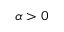Convert formula to latex. <formula><loc_0><loc_0><loc_500><loc_500>\alpha > 0</formula> 